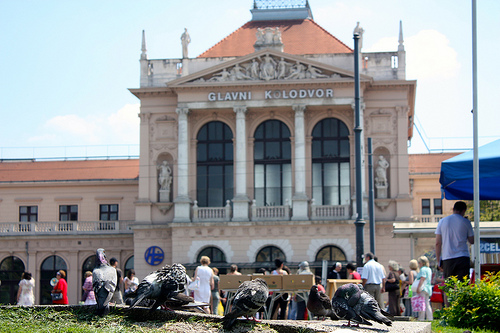<image>
Is the person on the cart? No. The person is not positioned on the cart. They may be near each other, but the person is not supported by or resting on top of the cart. Is the bird behind the building? No. The bird is not behind the building. From this viewpoint, the bird appears to be positioned elsewhere in the scene. 